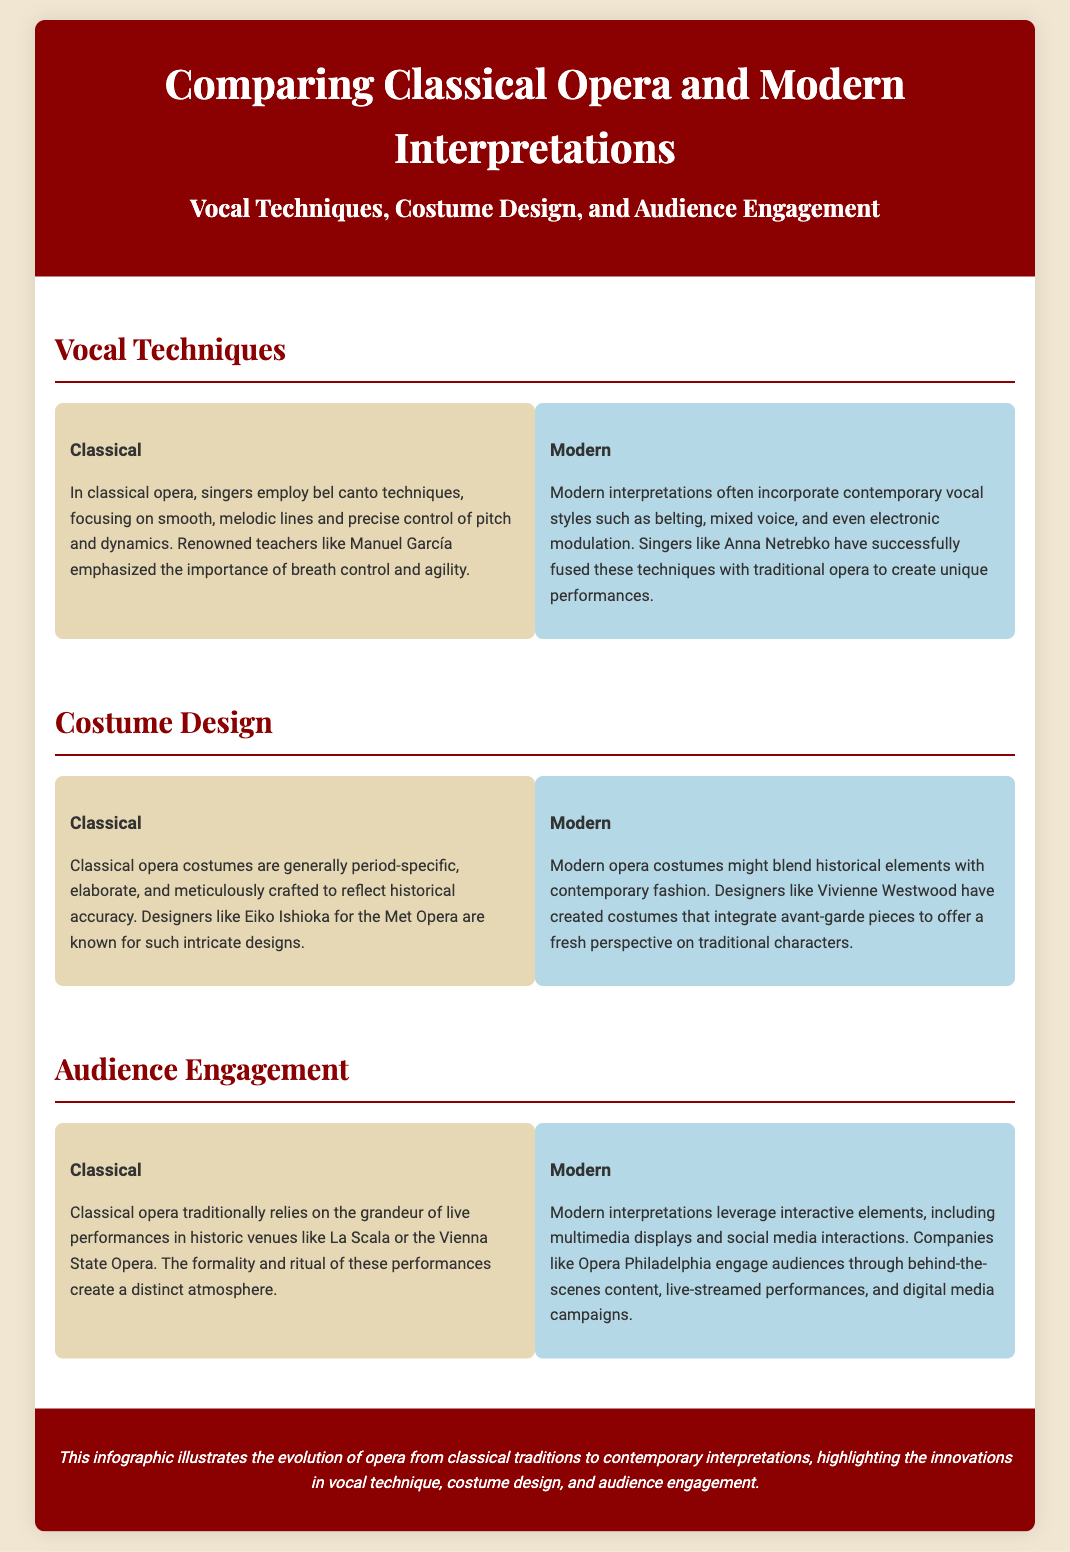What vocal technique is emphasized in classical opera? The document states that classical opera emphasizes bel canto techniques, which focus on smooth, melodic lines and control.
Answer: bel canto techniques Who are some modern interpreters that blend contemporary styles with opera? The document mentions Anna Netrebko as a modern interpreter who successfully fuses contemporary vocal styles with traditional opera.
Answer: Anna Netrebko What is a characteristic of classical opera costumes? Classical opera costumes are described as period-specific, elaborate, and crafted for historical accuracy.
Answer: period-specific Which designer is noted for creating intricate classical opera costumes? The document mentions Eiko Ishioka as a designer known for elaborate costume designs for classical opera.
Answer: Eiko Ishioka What type of atmosphere do classical opera performances create? The document indicates that classical performances create a distinct atmosphere due to their grandeur and formality in historic venues.
Answer: distinct atmosphere How do modern opera performances engage with audiences? The document states that modern performances leverage interactive elements like multimedia displays and social media interactions.
Answer: interactive elements What is one way Opera Philadelphia engages its audience? The document mentions that Opera Philadelphia uses behind-the-scenes content and live-streamed performances to engage audiences.
Answer: behind-the-scenes content What historical venues are mentioned in relation to classical opera? The document includes La Scala and the Vienna State Opera as historic venues for classical opera.
Answer: La Scala, Vienna State Opera 